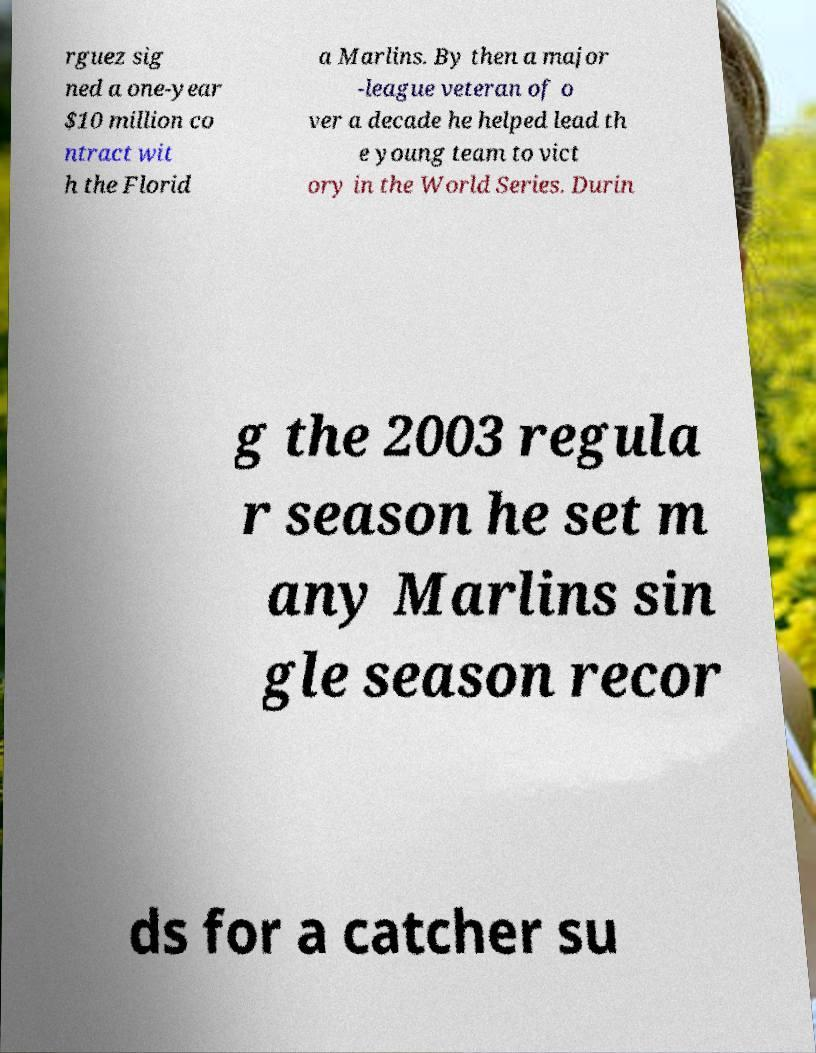Could you assist in decoding the text presented in this image and type it out clearly? rguez sig ned a one-year $10 million co ntract wit h the Florid a Marlins. By then a major -league veteran of o ver a decade he helped lead th e young team to vict ory in the World Series. Durin g the 2003 regula r season he set m any Marlins sin gle season recor ds for a catcher su 